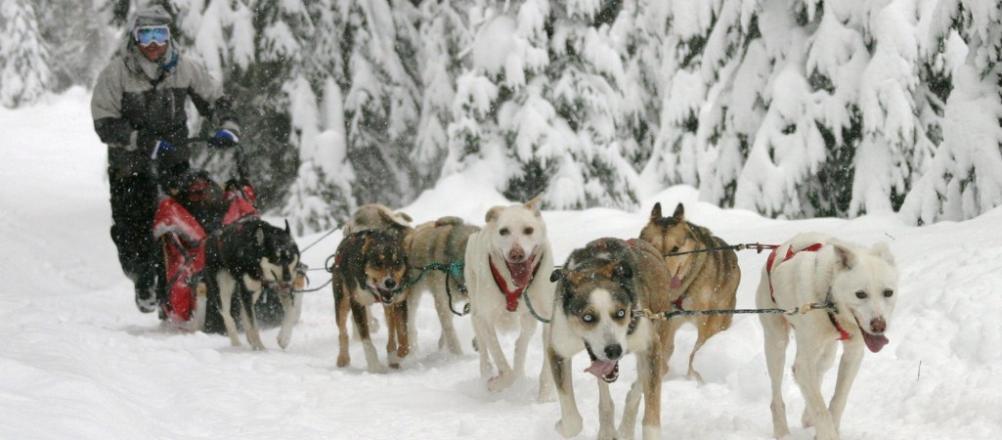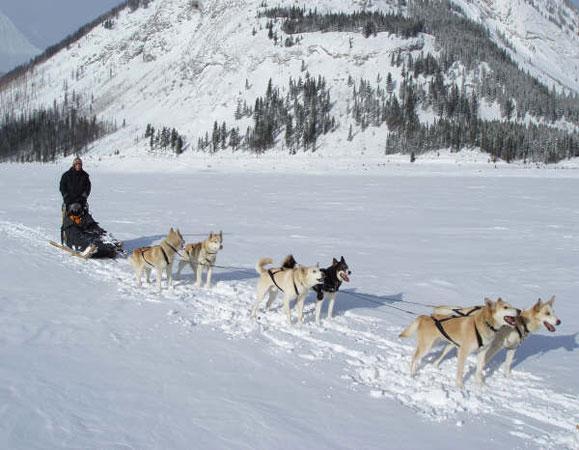The first image is the image on the left, the second image is the image on the right. Analyze the images presented: Is the assertion "In the left image, one of the lead dogs is white." valid? Answer yes or no. Yes. 